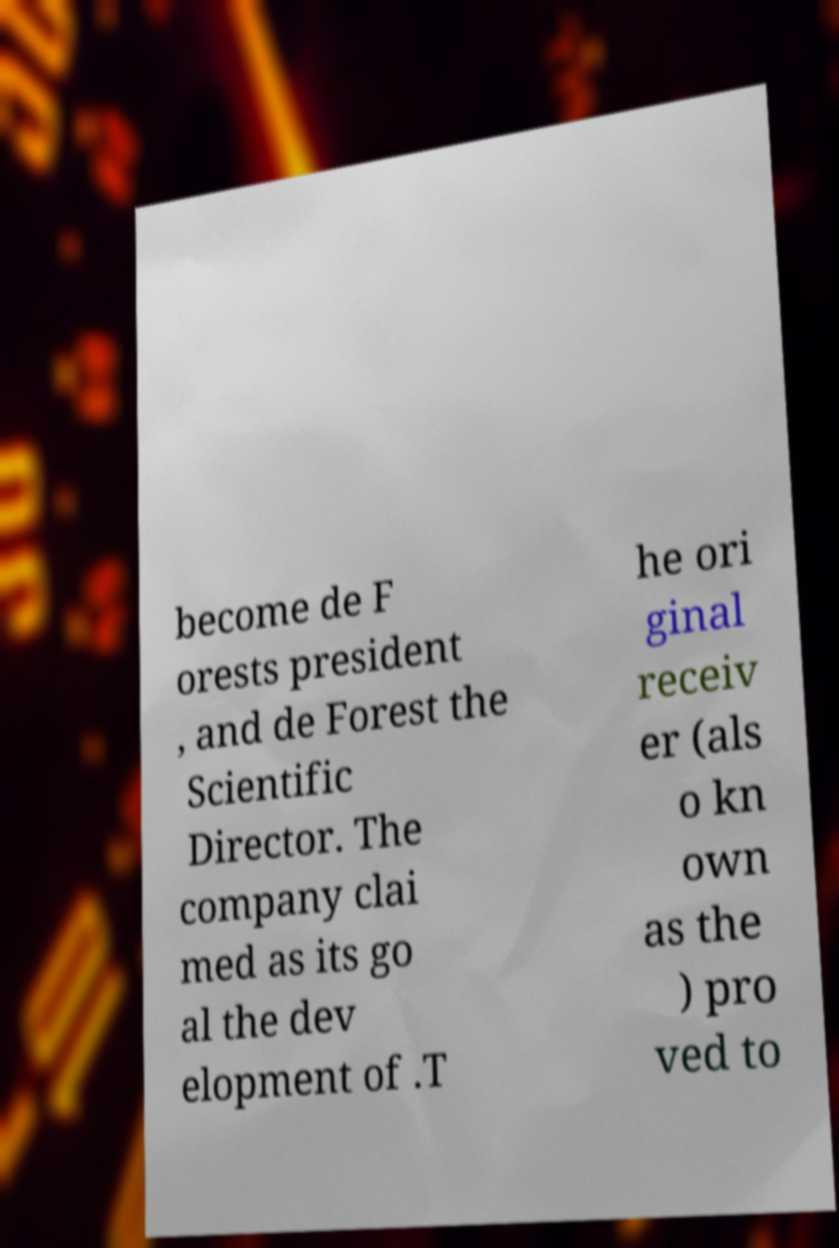Please read and relay the text visible in this image. What does it say? become de F orests president , and de Forest the Scientific Director. The company clai med as its go al the dev elopment of .T he ori ginal receiv er (als o kn own as the ) pro ved to 